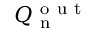Convert formula to latex. <formula><loc_0><loc_0><loc_500><loc_500>Q _ { n } ^ { o u t }</formula> 